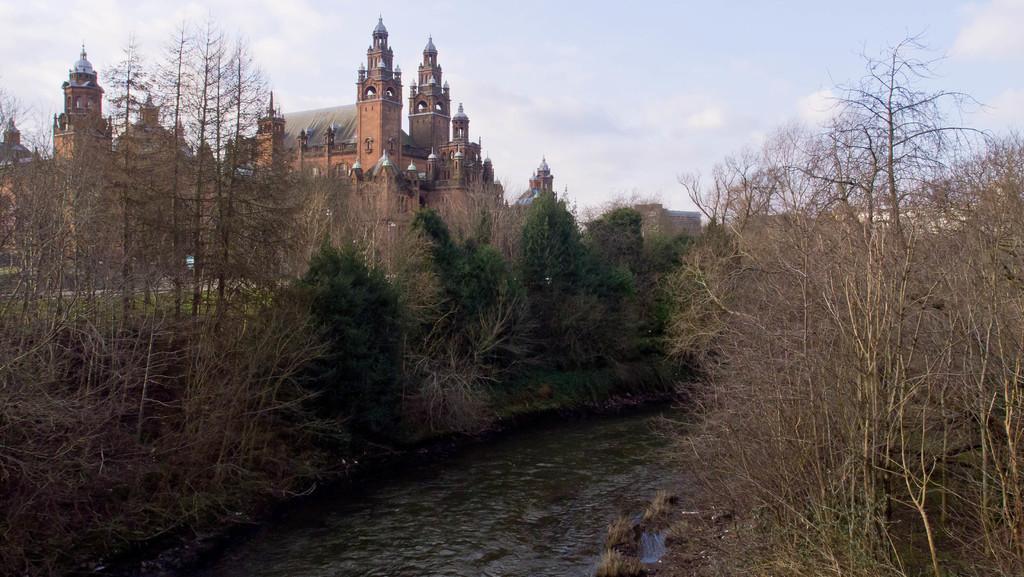Could you give a brief overview of what you see in this image? In this image we can see the water and there are some plants and trees and we can see a building which looks like a palace in the background and at the top we can see the sky. 